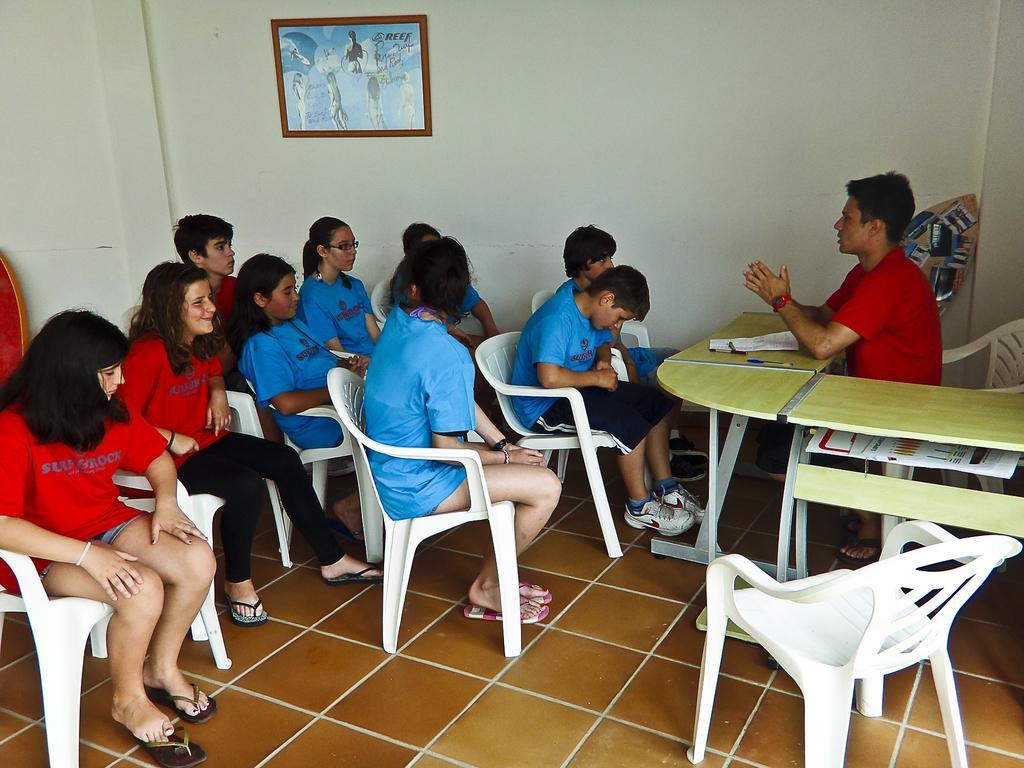Can you describe this image briefly? in this picture there are group of people sitting on the chair,a person was explaining them by sitting on chair having a table in front of them, there was a frame on the wall. 